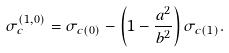Convert formula to latex. <formula><loc_0><loc_0><loc_500><loc_500>\sigma _ { c } ^ { ( 1 , 0 ) } = \sigma _ { c ( 0 ) } - \left ( 1 - \frac { a ^ { 2 } } { b ^ { 2 } } \right ) \sigma _ { c ( 1 ) } .</formula> 